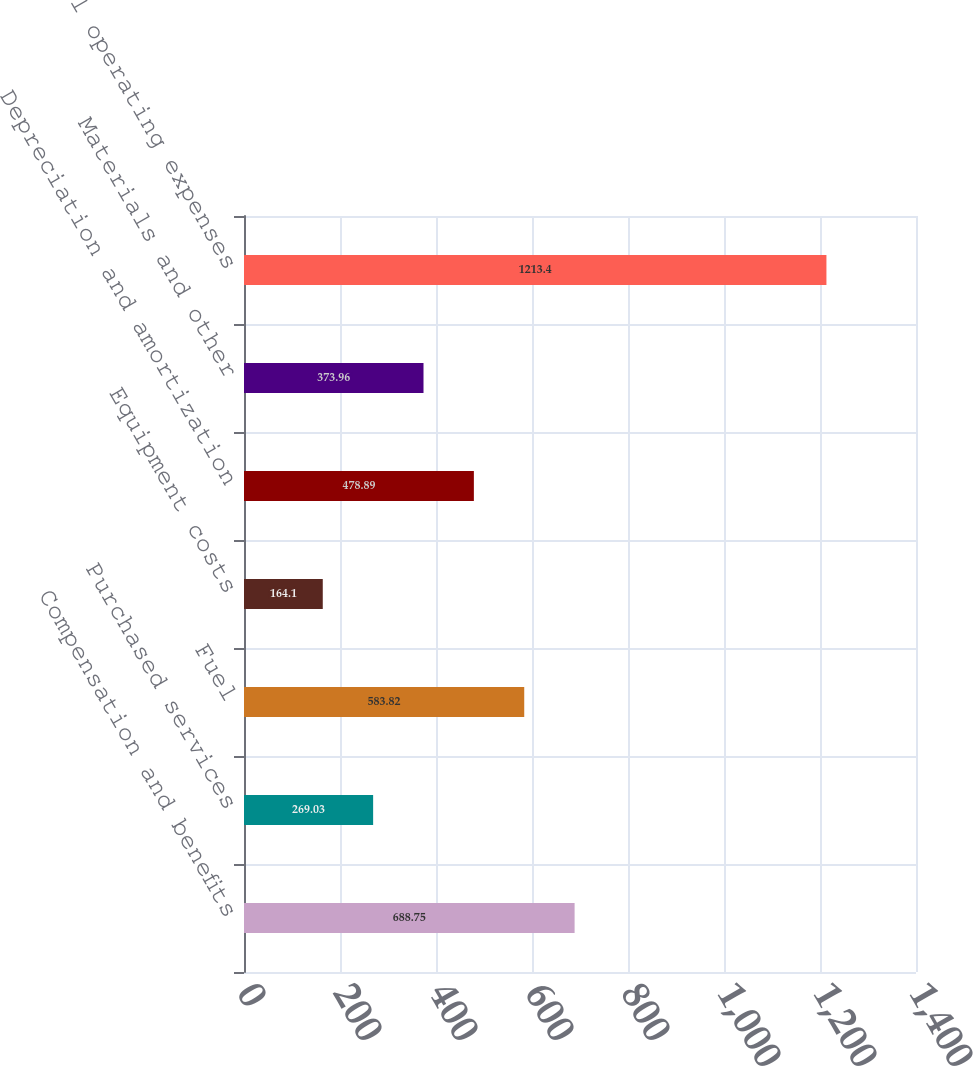<chart> <loc_0><loc_0><loc_500><loc_500><bar_chart><fcel>Compensation and benefits<fcel>Purchased services<fcel>Fuel<fcel>Equipment costs<fcel>Depreciation and amortization<fcel>Materials and other<fcel>Total operating expenses<nl><fcel>688.75<fcel>269.03<fcel>583.82<fcel>164.1<fcel>478.89<fcel>373.96<fcel>1213.4<nl></chart> 